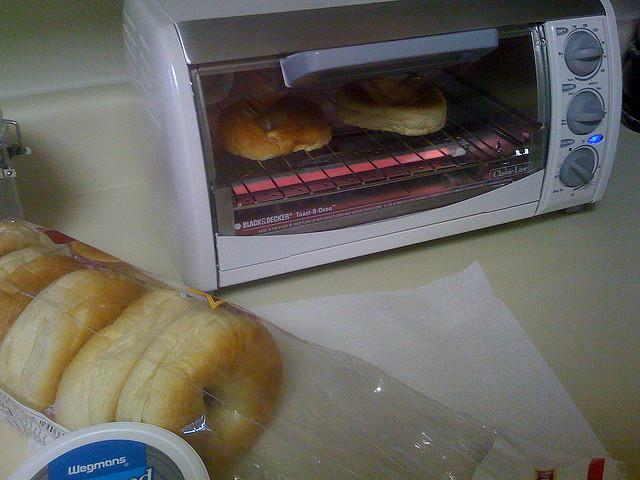Why is the bagel in there? Please explain your reasoning. toasting. The bagels are toasting. 